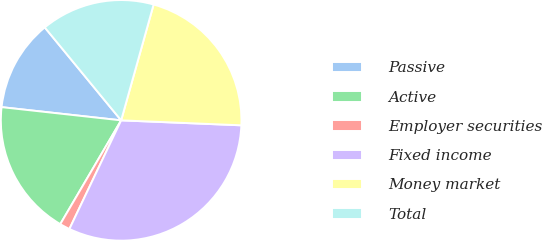Convert chart to OTSL. <chart><loc_0><loc_0><loc_500><loc_500><pie_chart><fcel>Passive<fcel>Active<fcel>Employer securities<fcel>Fixed income<fcel>Money market<fcel>Total<nl><fcel>12.3%<fcel>18.31%<fcel>1.37%<fcel>31.42%<fcel>21.31%<fcel>15.3%<nl></chart> 